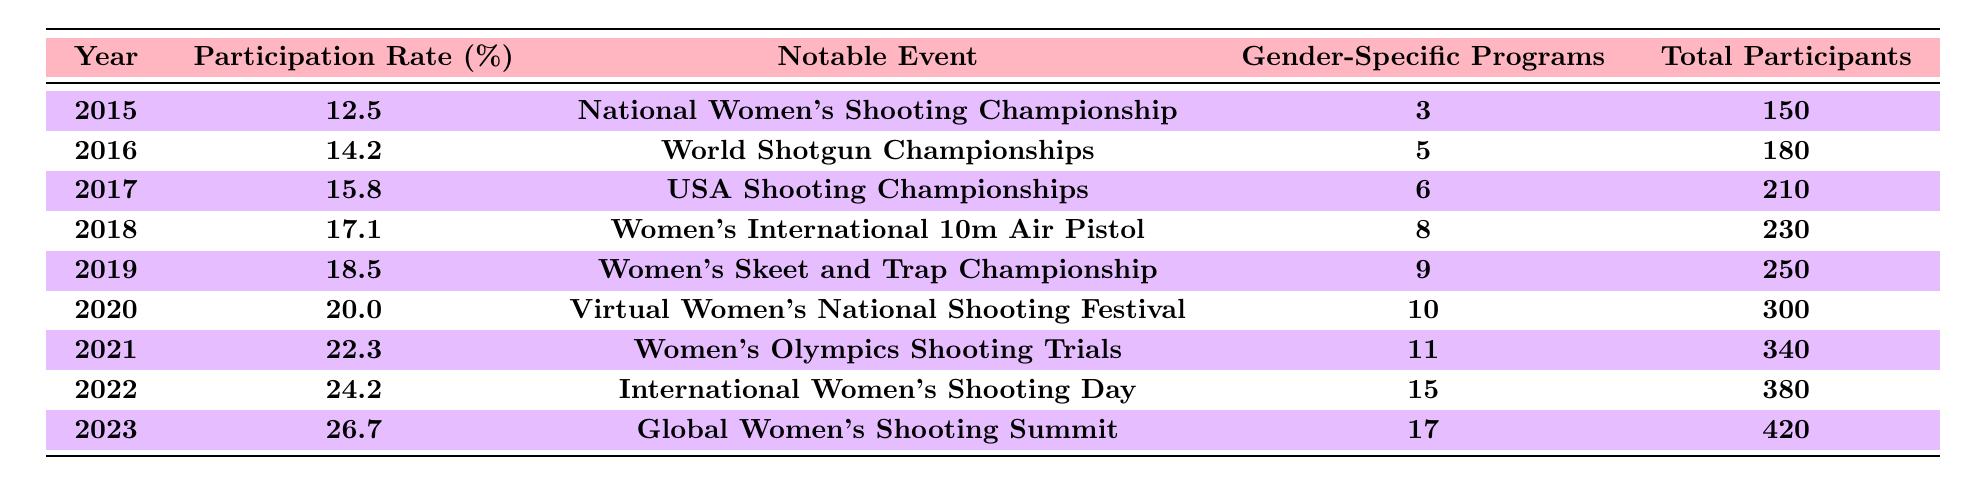What was the participation rate for women in shooting sports in 2015? The table indicates the participation rate for women in shooting sports in 2015 is 12.5%.
Answer: 12.5% Which year had the highest number of gender-specific programs? The table shows that 2023 had 17 gender-specific programs, which is the highest compared to other years.
Answer: 2023 What notable event occurred in 2020? According to the table, the notable event in 2020 was the "Virtual Women’s National Shooting Festival."
Answer: Virtual Women’s National Shooting Festival Calculate the total participants across all years listed in the table. By summing the total participants for all years: 150 + 180 + 210 + 230 + 250 + 300 + 340 + 380 + 420 = 2160.
Answer: 2160 Did the participation rate for women increase every year from 2015 to 2023? The table indicates that the participation rate increased every year from 2015 (12.5%) to 2023 (26.7%).
Answer: Yes What was the average participation rate from 2015 to 2023? To find the average, sum all participation rates: (12.5 + 14.2 + 15.8 + 17.1 + 18.5 + 20.0 + 22.3 + 24.2 + 26.7) = 151.3, then divide by 9 years: 151.3 / 9 = 16.79.
Answer: 16.79 In which year was the participation rate above 20% for the first time? The table indicates that the participation rate first exceeded 20% in 2020 (20.0%).
Answer: 2020 How many total participants were there in 2022? According to the table, the total participants in 2022 were 380.
Answer: 380 Which notable event corresponds with the highest participation rate? The table shows that the highest participation rate (26.7%) corresponds with the "Global Women's Shooting Summit" in 2023.
Answer: Global Women's Shooting Summit What was the increase in participation rate from 2016 to 2017? The participation rate increased from 14.2% in 2016 to 15.8% in 2017, so the increase is 15.8 - 14.2 = 1.6%.
Answer: 1.6% 